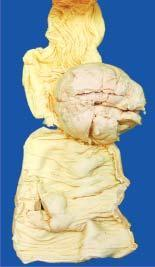what is seen projecting into lumen while the covering mucosa is ulcerated?
Answer the question using a single word or phrase. Polypoid growth 